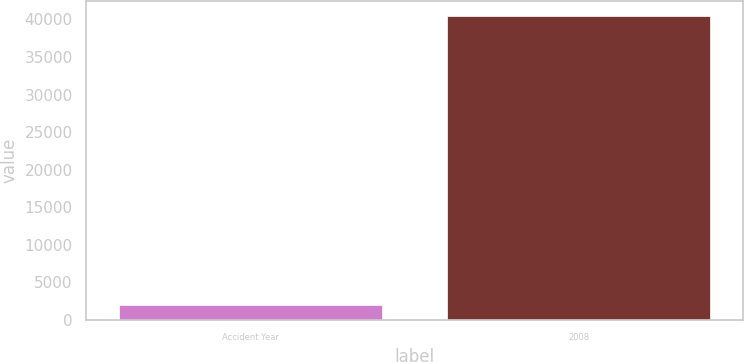Convert chart. <chart><loc_0><loc_0><loc_500><loc_500><bar_chart><fcel>Accident Year<fcel>2008<nl><fcel>2015<fcel>40490<nl></chart> 